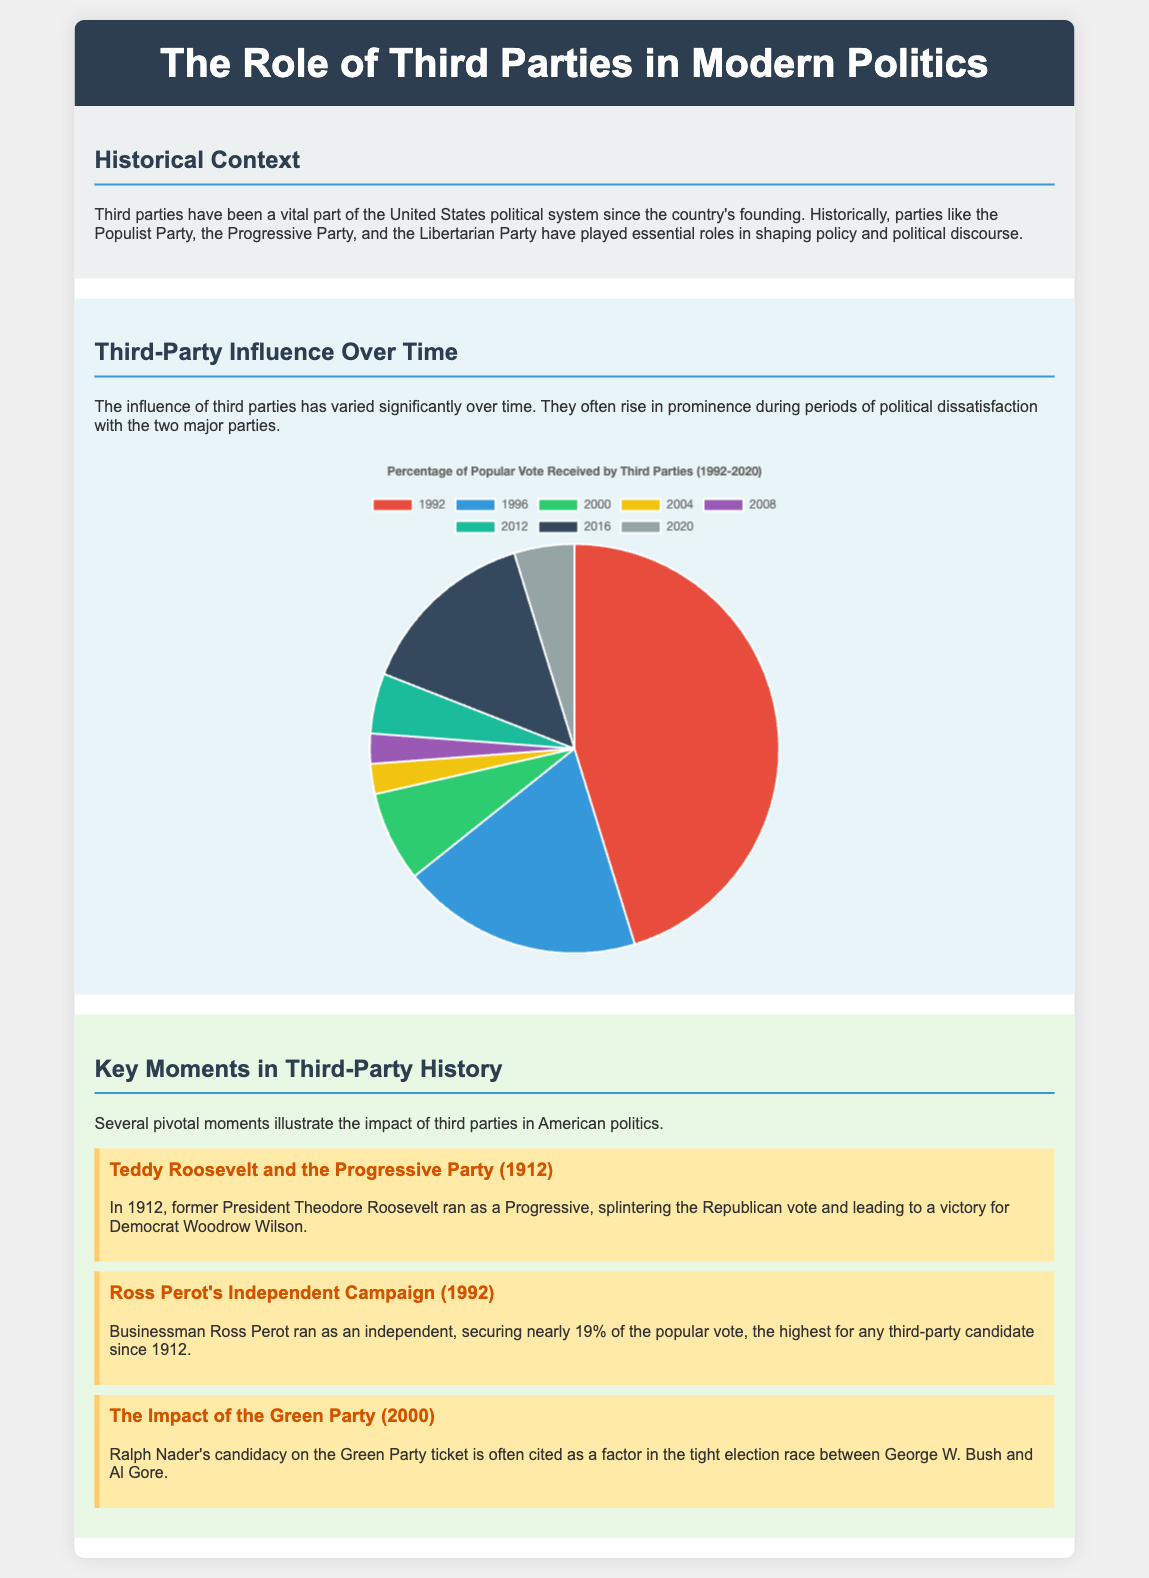What is the title of the poster? The title of the poster is displayed prominently at the top and reads "The Role of Third Parties in Modern Politics."
Answer: The Role of Third Parties in Modern Politics Who ran as a Progressive in 1912? The document highlights that Theodore Roosevelt ran as a Progressive in the year 1912.
Answer: Theodore Roosevelt What percentage of the popular vote did Ross Perot secure in 1992? The poster states that Ross Perot secured nearly 19% of the popular vote in 1992.
Answer: 19% Which party's candidacy is cited as a factor in the 2000 election race? Ralph Nader's candidacy on the Green Party ticket is mentioned in the context of the 2000 election race.
Answer: Green Party What was the trend in third-party influence from 2000 to 2004? The document shows that the percentage of the popular vote for third parties decreased from 3% in 2000 to 1% in 2004.
Answer: Decreased How many years did the pie chart cover for third-party influence? The pie chart covers data from 1992 to 2020, providing insight over a span of years.
Answer: 28 years Which two major parties are primarily discussed in relation to third-party influence? The document focuses on the two major parties, which are the Democrats and Republicans.
Answer: Democrats and Republicans What was the background color of the "Key Moments in Third-Party History" section? The section for "Key Moments in Third-Party History" has a contrasting background color of light green as indicated in the document.
Answer: Light green 